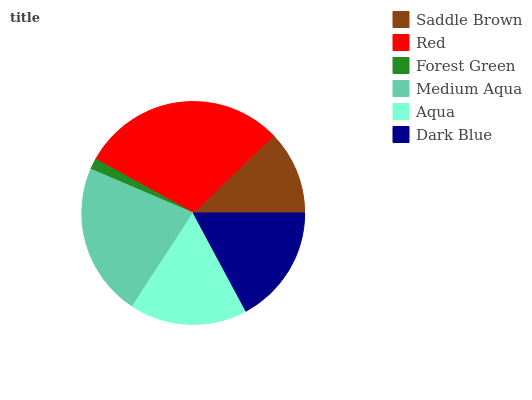Is Forest Green the minimum?
Answer yes or no. Yes. Is Red the maximum?
Answer yes or no. Yes. Is Red the minimum?
Answer yes or no. No. Is Forest Green the maximum?
Answer yes or no. No. Is Red greater than Forest Green?
Answer yes or no. Yes. Is Forest Green less than Red?
Answer yes or no. Yes. Is Forest Green greater than Red?
Answer yes or no. No. Is Red less than Forest Green?
Answer yes or no. No. Is Dark Blue the high median?
Answer yes or no. Yes. Is Aqua the low median?
Answer yes or no. Yes. Is Forest Green the high median?
Answer yes or no. No. Is Medium Aqua the low median?
Answer yes or no. No. 